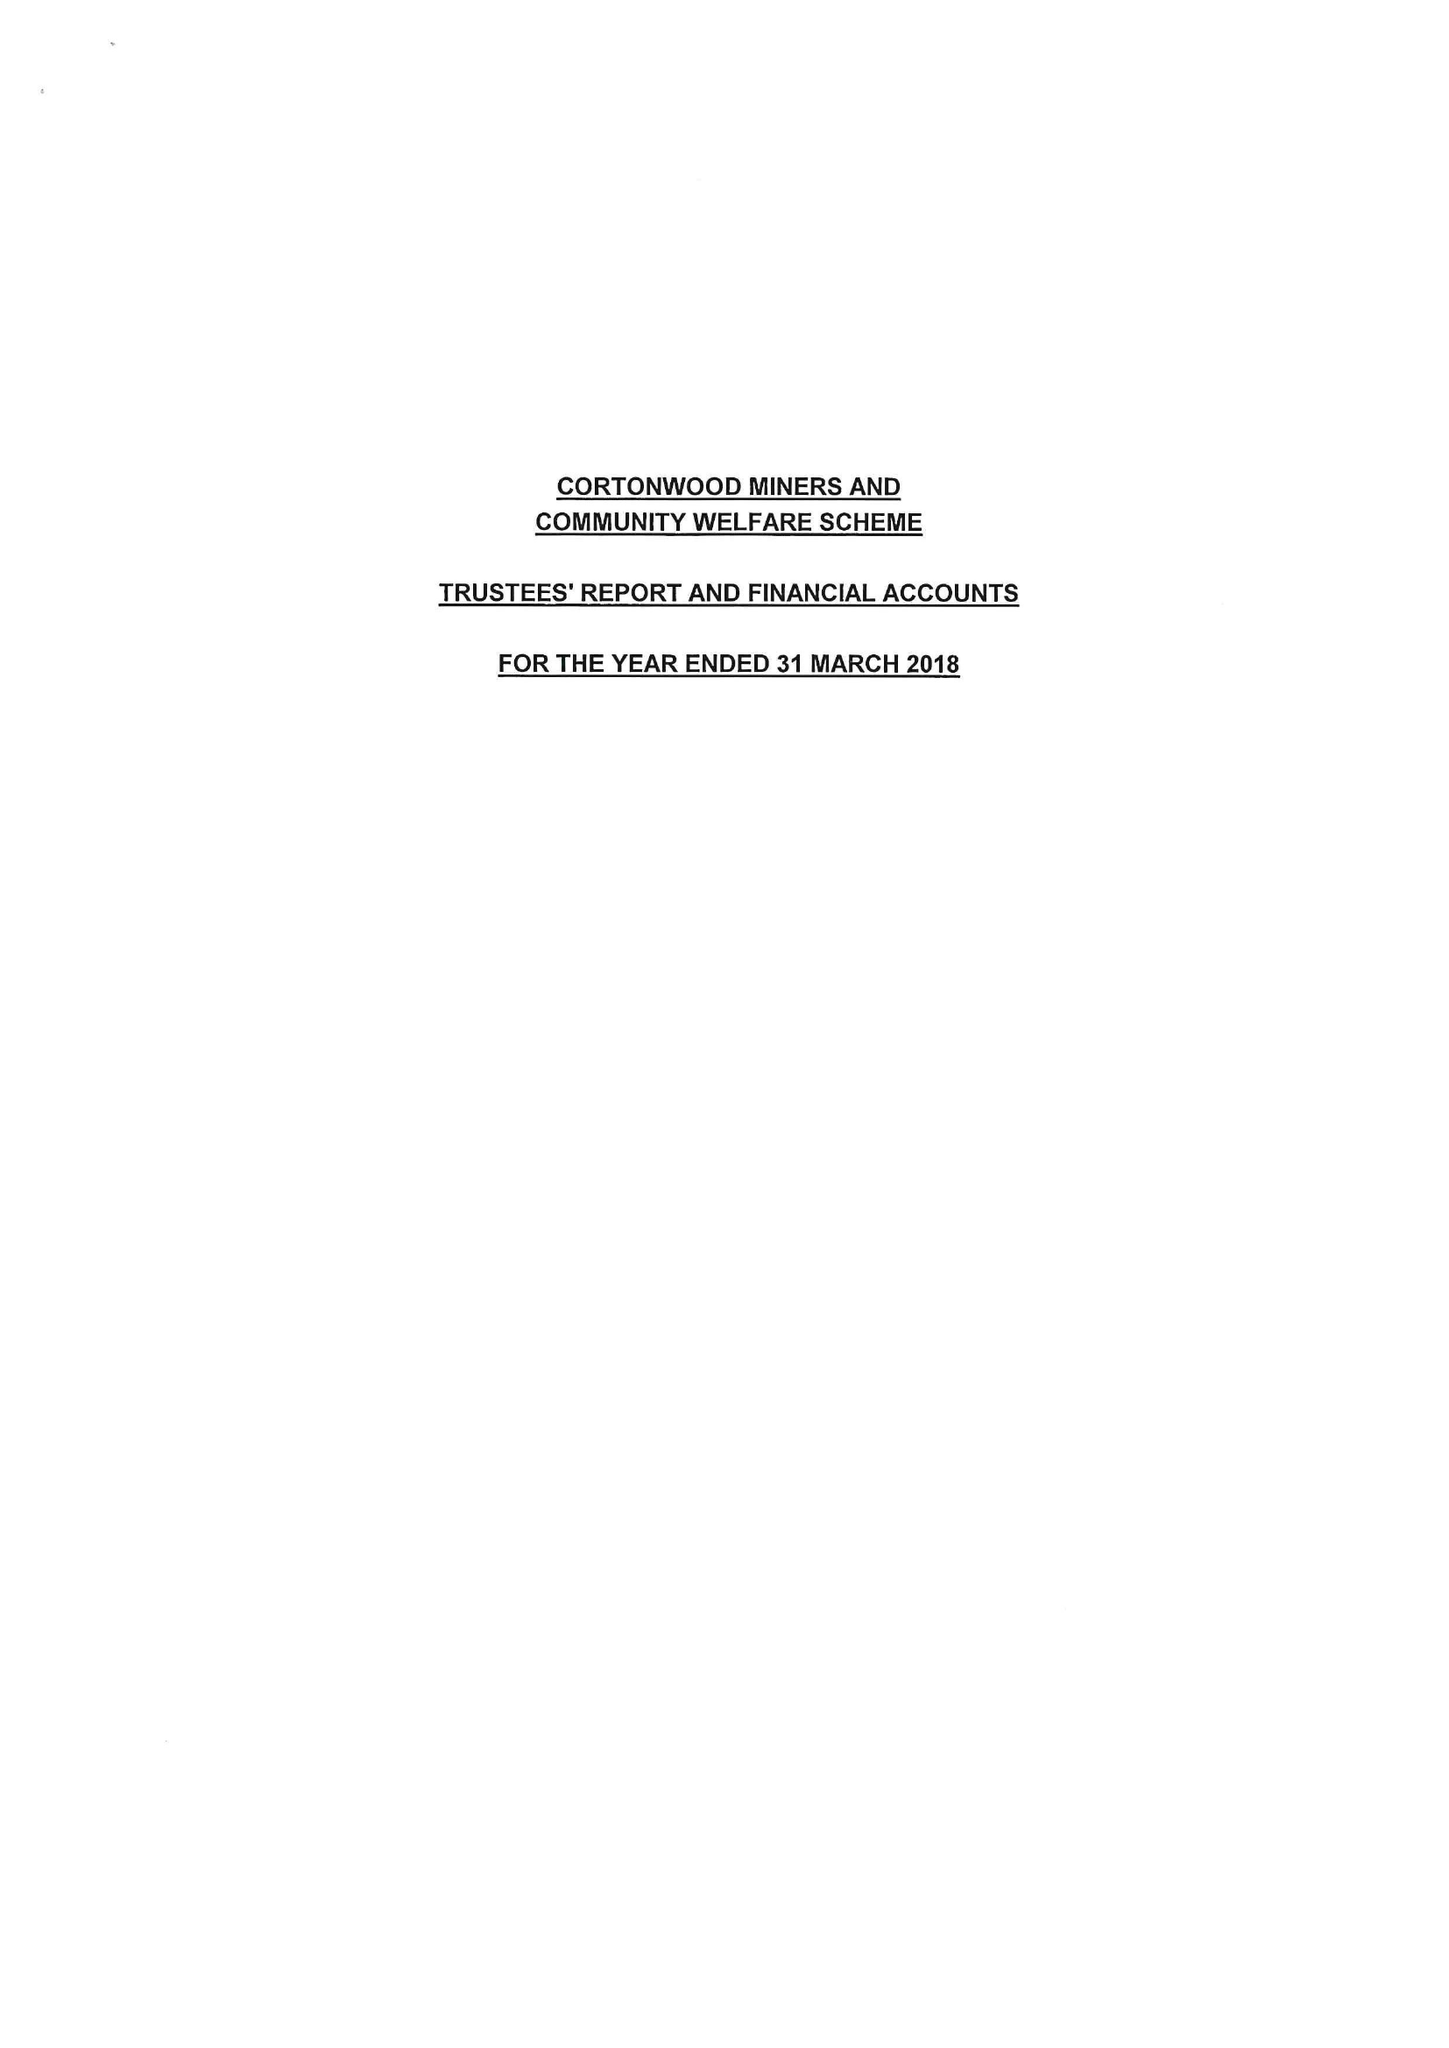What is the value for the address__street_line?
Answer the question using a single word or phrase. None 